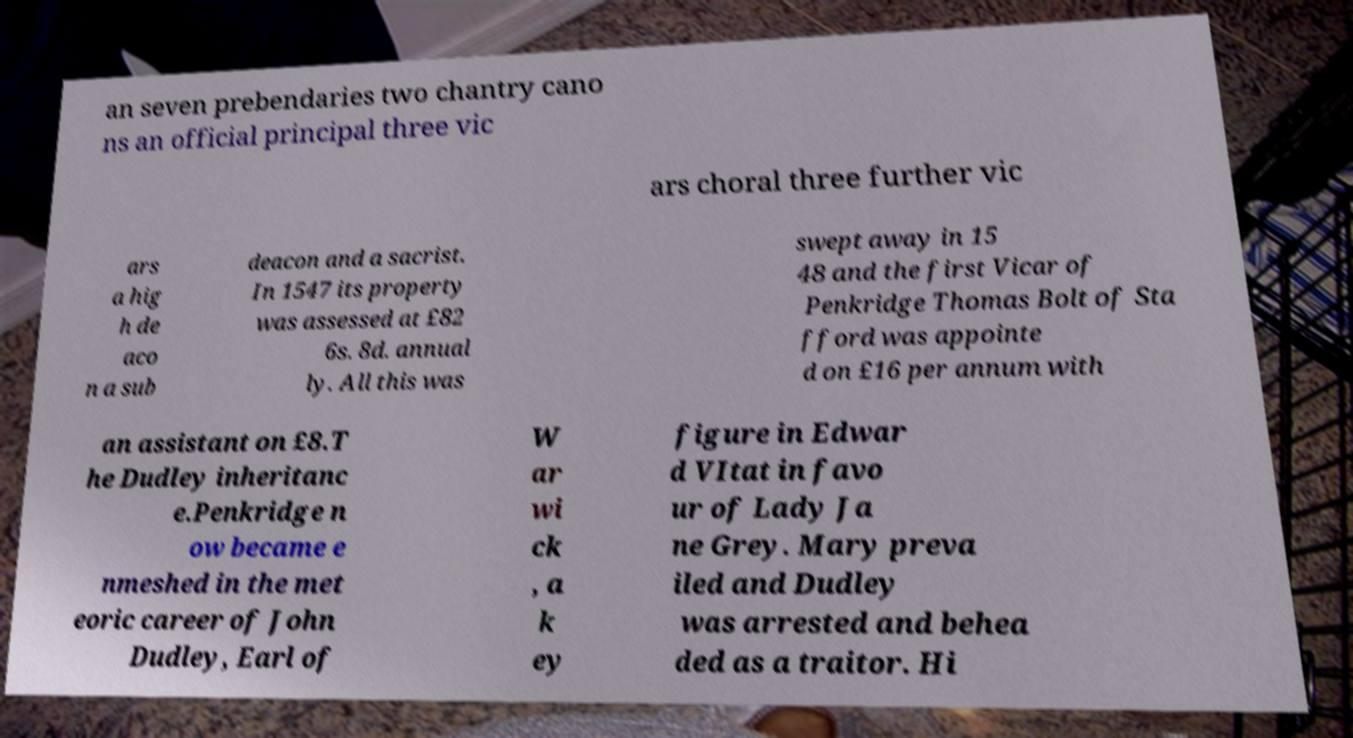I need the written content from this picture converted into text. Can you do that? an seven prebendaries two chantry cano ns an official principal three vic ars choral three further vic ars a hig h de aco n a sub deacon and a sacrist. In 1547 its property was assessed at £82 6s. 8d. annual ly. All this was swept away in 15 48 and the first Vicar of Penkridge Thomas Bolt of Sta fford was appointe d on £16 per annum with an assistant on £8.T he Dudley inheritanc e.Penkridge n ow became e nmeshed in the met eoric career of John Dudley, Earl of W ar wi ck , a k ey figure in Edwar d VItat in favo ur of Lady Ja ne Grey. Mary preva iled and Dudley was arrested and behea ded as a traitor. Hi 